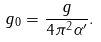<formula> <loc_0><loc_0><loc_500><loc_500>g _ { 0 } = \frac { g } { 4 \pi ^ { 2 } \alpha ^ { \prime } } .</formula> 